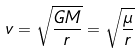<formula> <loc_0><loc_0><loc_500><loc_500>v = \sqrt { \frac { G M } { r } } = \sqrt { \frac { \mu } { r } }</formula> 